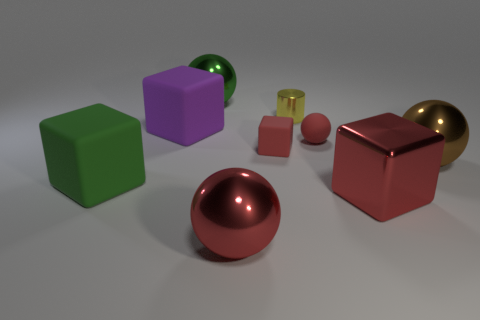How does the lighting affect the mood or tone of the image? The lighting in the image provides a calming and serene atmosphere through its softness and subtlety. It imbues the scene with a sense of tranquility. The gentle shadows under each object give the composition depth and grounding, while the soft highlights on the metallic surfaces create a meditative gleam that invites contemplation. The overall effect is one of harmony and balance, making the image pleasing to the eye and soothing to the mind. 